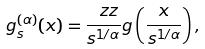<formula> <loc_0><loc_0><loc_500><loc_500>g _ { s } ^ { ( \alpha ) } ( x ) = \frac { \ z z } { s ^ { 1 / \alpha } } g \left ( \frac { x } { s ^ { 1 / \alpha } } \right ) ,</formula> 